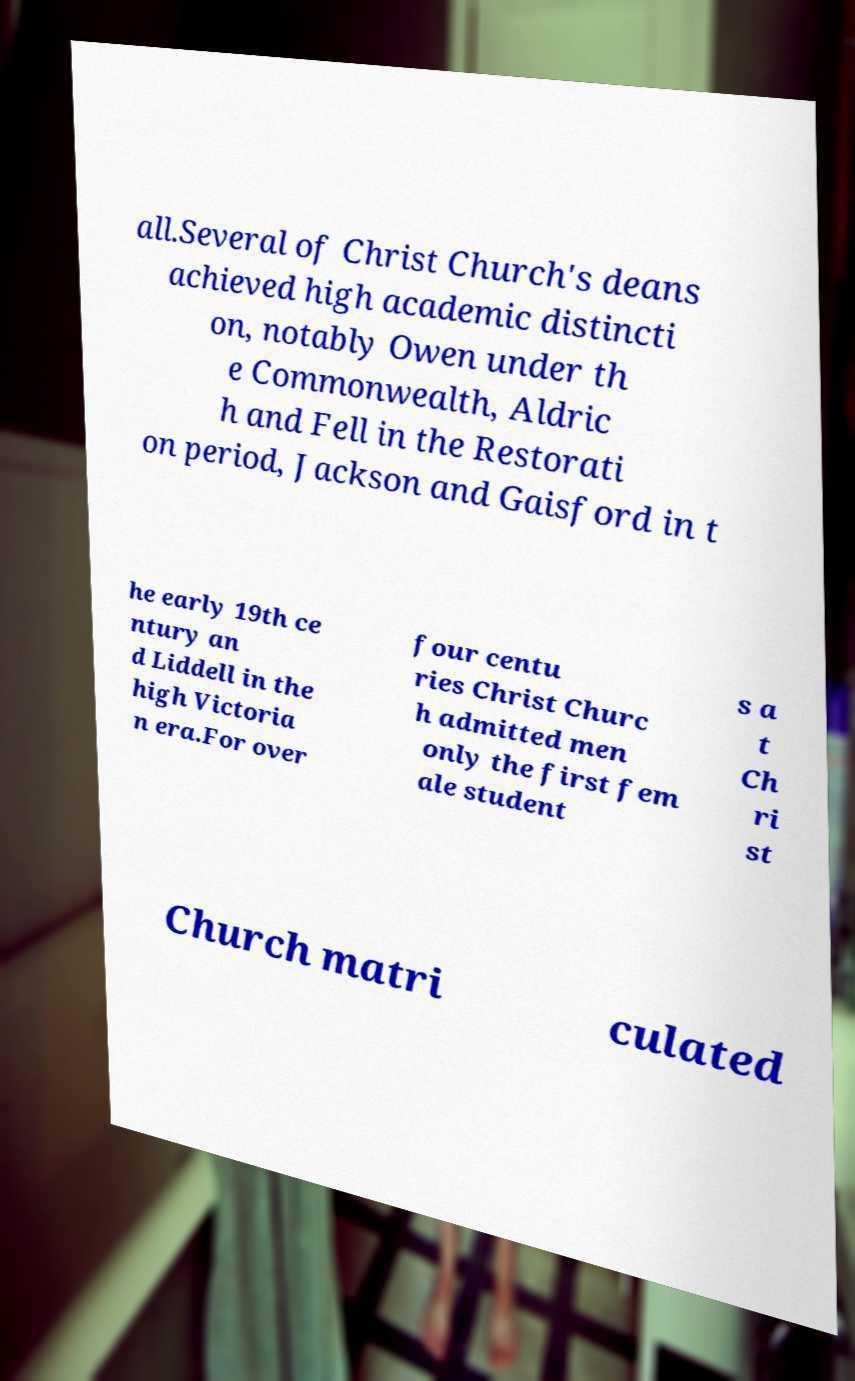Could you extract and type out the text from this image? all.Several of Christ Church's deans achieved high academic distincti on, notably Owen under th e Commonwealth, Aldric h and Fell in the Restorati on period, Jackson and Gaisford in t he early 19th ce ntury an d Liddell in the high Victoria n era.For over four centu ries Christ Churc h admitted men only the first fem ale student s a t Ch ri st Church matri culated 